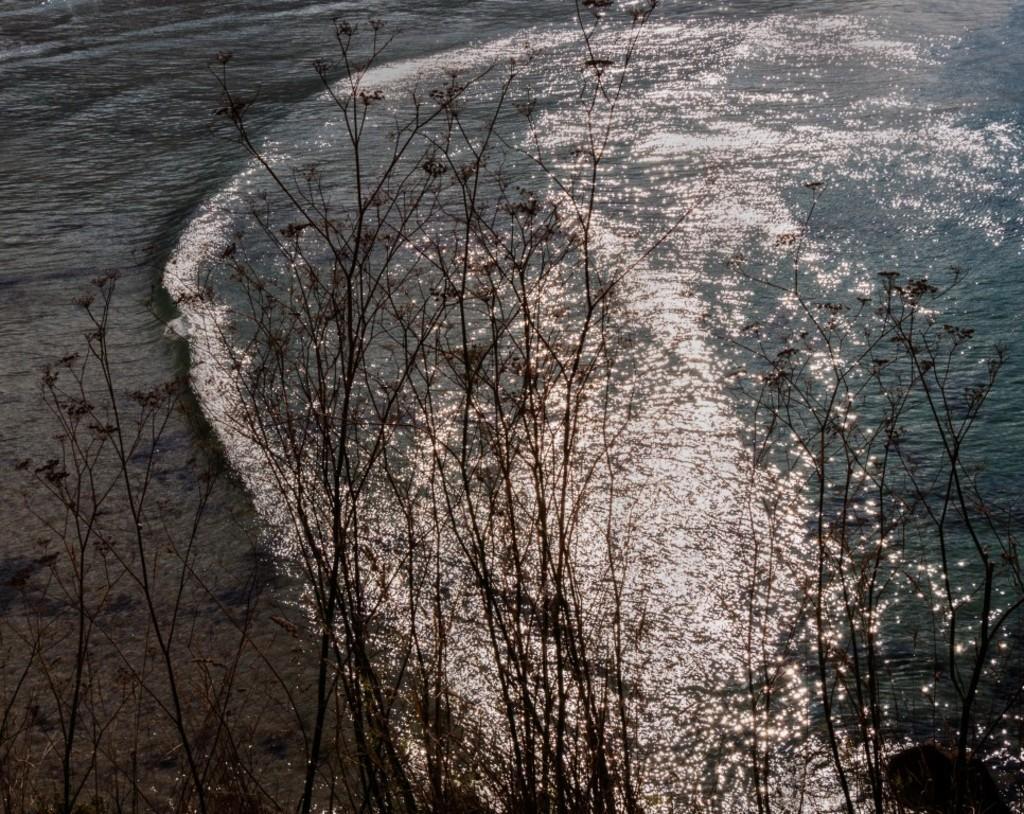How would you summarize this image in a sentence or two? In this image we can see trees. Also there is water. 